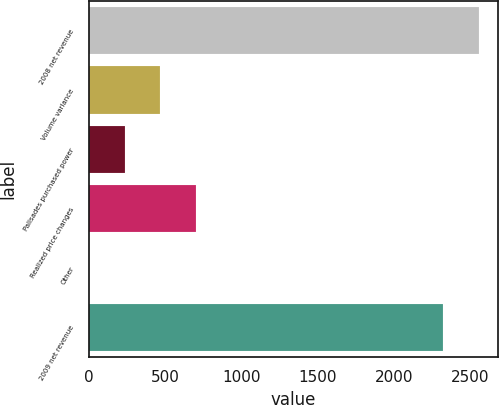Convert chart. <chart><loc_0><loc_0><loc_500><loc_500><bar_chart><fcel>2008 net revenue<fcel>Volume variance<fcel>Palisades purchased power<fcel>Realized price changes<fcel>Other<fcel>2009 net revenue<nl><fcel>2556.2<fcel>468.4<fcel>235.2<fcel>701.6<fcel>2<fcel>2323<nl></chart> 